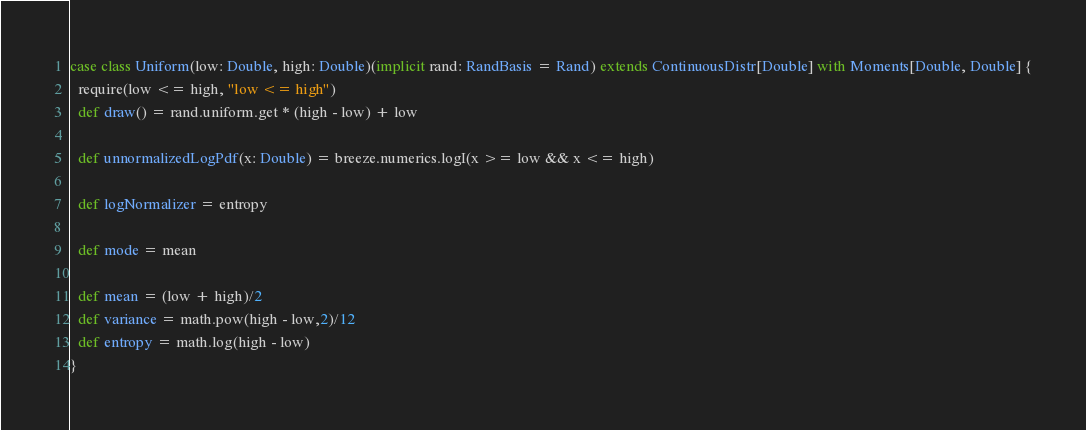<code> <loc_0><loc_0><loc_500><loc_500><_Scala_>case class Uniform(low: Double, high: Double)(implicit rand: RandBasis = Rand) extends ContinuousDistr[Double] with Moments[Double, Double] {
  require(low <= high, "low <= high")
  def draw() = rand.uniform.get * (high - low) + low

  def unnormalizedLogPdf(x: Double) = breeze.numerics.logI(x >= low && x <= high)

  def logNormalizer = entropy

  def mode = mean

  def mean = (low + high)/2
  def variance = math.pow(high - low,2)/12
  def entropy = math.log(high - low)
}</code> 